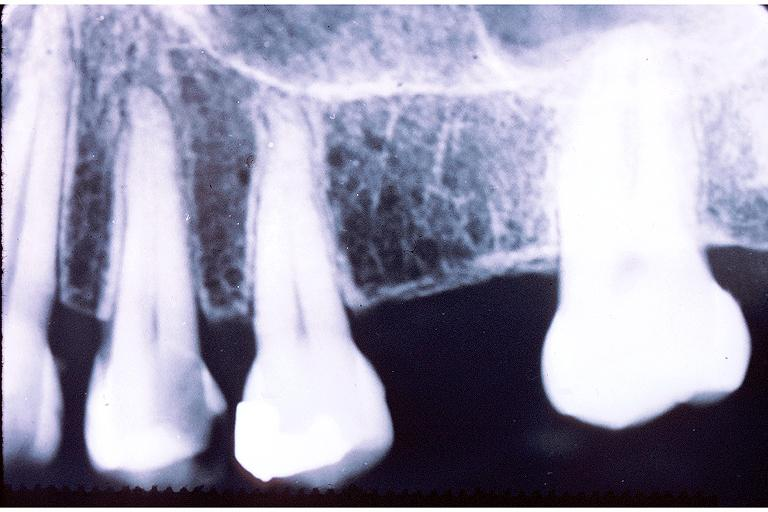s oral present?
Answer the question using a single word or phrase. Yes 